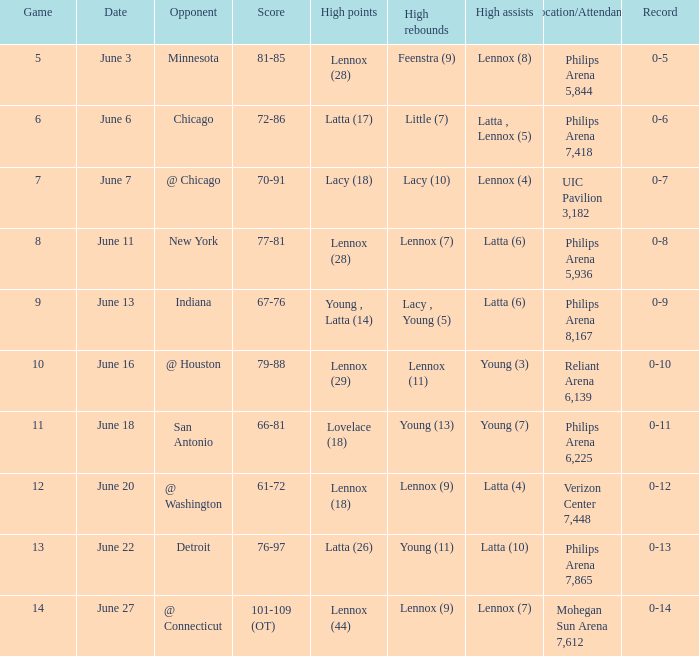Who made the highest assist in the game that scored 79-88? Young (3). 